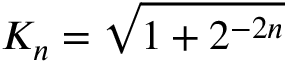Convert formula to latex. <formula><loc_0><loc_0><loc_500><loc_500>K _ { n } = { \sqrt { 1 + 2 ^ { - 2 n } } }</formula> 